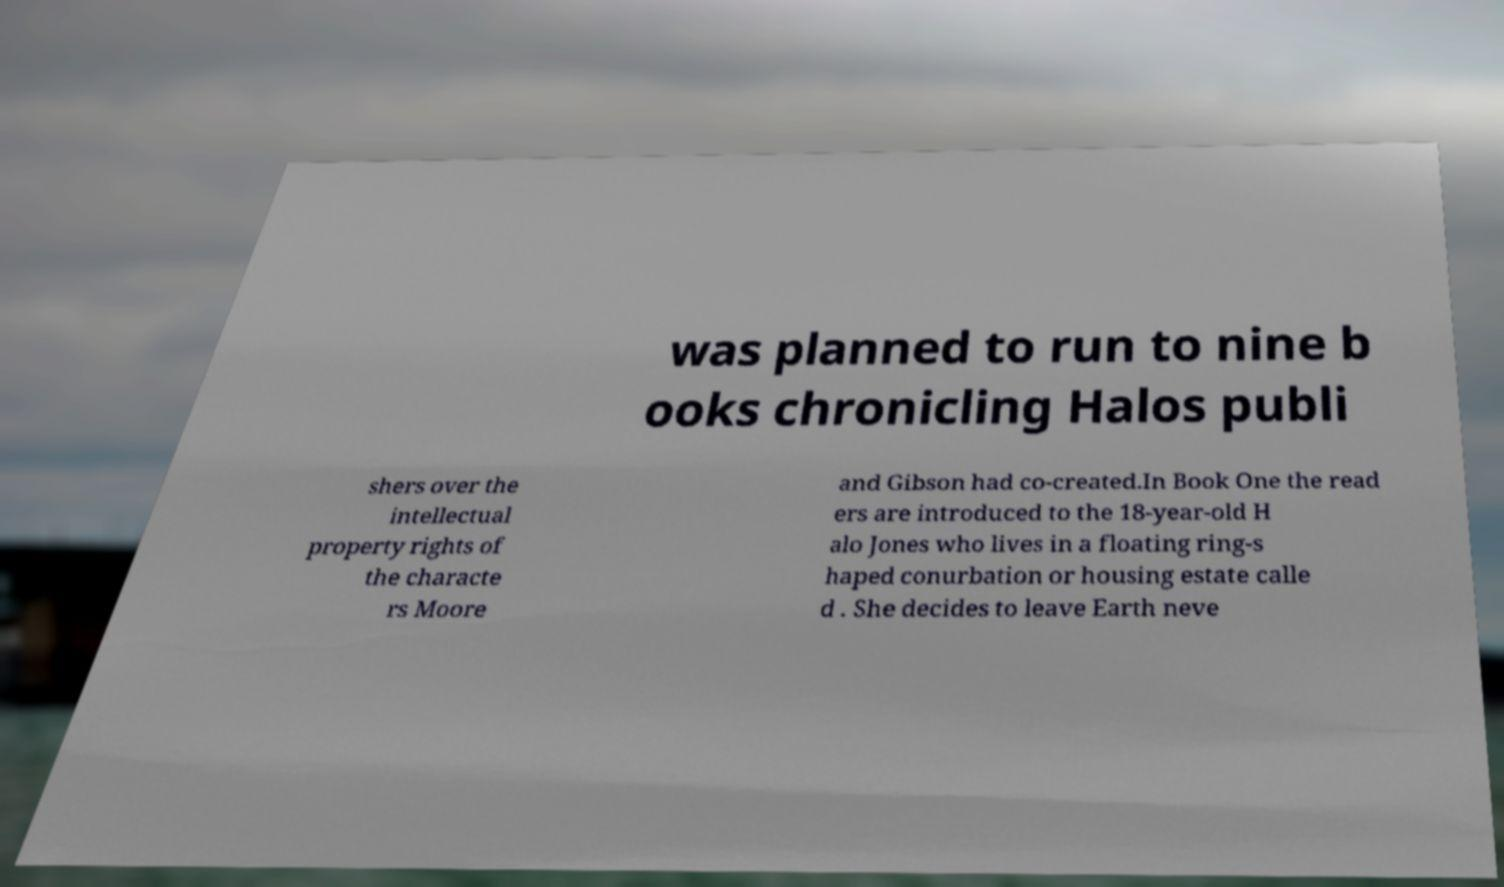What messages or text are displayed in this image? I need them in a readable, typed format. was planned to run to nine b ooks chronicling Halos publi shers over the intellectual property rights of the characte rs Moore and Gibson had co-created.In Book One the read ers are introduced to the 18-year-old H alo Jones who lives in a floating ring-s haped conurbation or housing estate calle d . She decides to leave Earth neve 